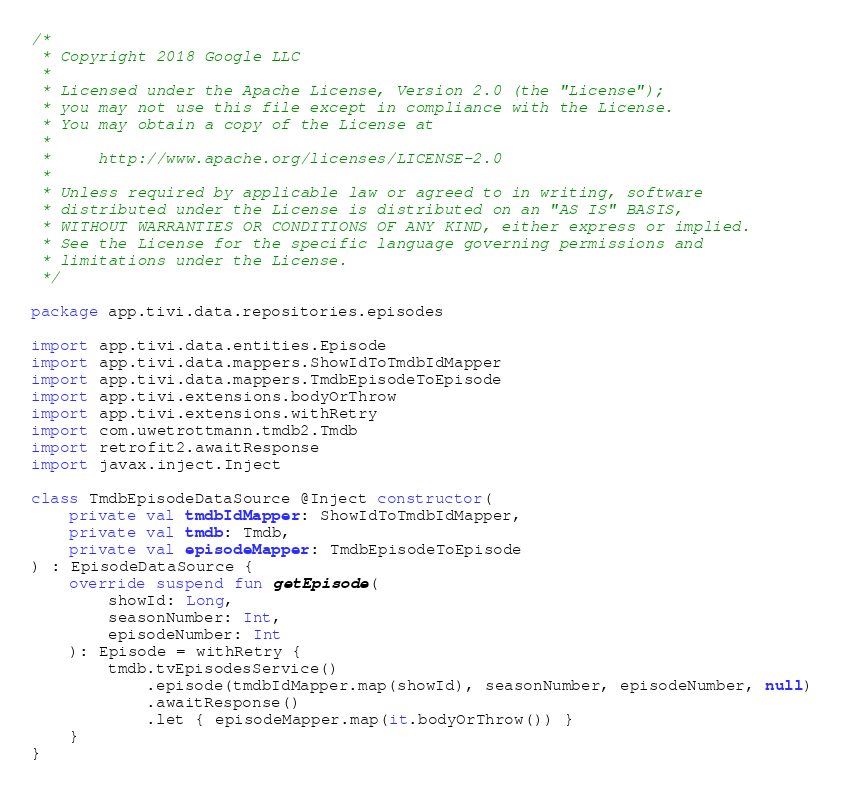<code> <loc_0><loc_0><loc_500><loc_500><_Kotlin_>/*
 * Copyright 2018 Google LLC
 *
 * Licensed under the Apache License, Version 2.0 (the "License");
 * you may not use this file except in compliance with the License.
 * You may obtain a copy of the License at
 *
 *     http://www.apache.org/licenses/LICENSE-2.0
 *
 * Unless required by applicable law or agreed to in writing, software
 * distributed under the License is distributed on an "AS IS" BASIS,
 * WITHOUT WARRANTIES OR CONDITIONS OF ANY KIND, either express or implied.
 * See the License for the specific language governing permissions and
 * limitations under the License.
 */

package app.tivi.data.repositories.episodes

import app.tivi.data.entities.Episode
import app.tivi.data.mappers.ShowIdToTmdbIdMapper
import app.tivi.data.mappers.TmdbEpisodeToEpisode
import app.tivi.extensions.bodyOrThrow
import app.tivi.extensions.withRetry
import com.uwetrottmann.tmdb2.Tmdb
import retrofit2.awaitResponse
import javax.inject.Inject

class TmdbEpisodeDataSource @Inject constructor(
    private val tmdbIdMapper: ShowIdToTmdbIdMapper,
    private val tmdb: Tmdb,
    private val episodeMapper: TmdbEpisodeToEpisode
) : EpisodeDataSource {
    override suspend fun getEpisode(
        showId: Long,
        seasonNumber: Int,
        episodeNumber: Int
    ): Episode = withRetry {
        tmdb.tvEpisodesService()
            .episode(tmdbIdMapper.map(showId), seasonNumber, episodeNumber, null)
            .awaitResponse()
            .let { episodeMapper.map(it.bodyOrThrow()) }
    }
}
</code> 